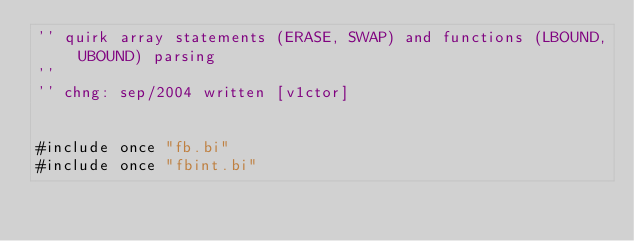Convert code to text. <code><loc_0><loc_0><loc_500><loc_500><_VisualBasic_>'' quirk array statements (ERASE, SWAP) and functions (LBOUND, UBOUND) parsing
''
'' chng: sep/2004 written [v1ctor]


#include once "fb.bi"
#include once "fbint.bi"</code> 